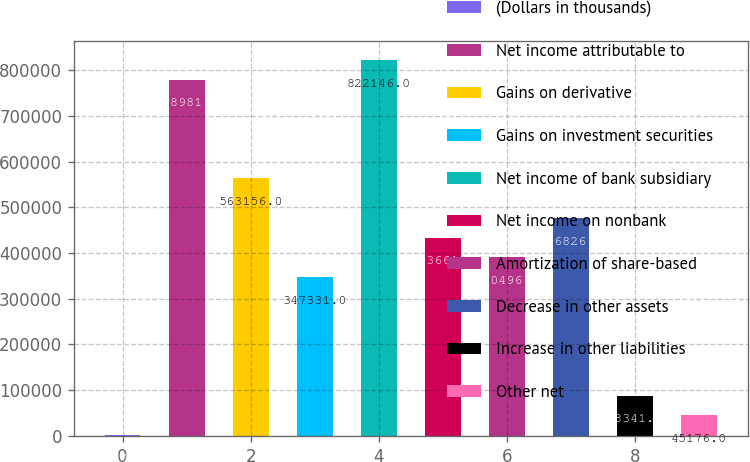Convert chart. <chart><loc_0><loc_0><loc_500><loc_500><bar_chart><fcel>(Dollars in thousands)<fcel>Net income attributable to<fcel>Gains on derivative<fcel>Gains on investment securities<fcel>Net income of bank subsidiary<fcel>Net income on nonbank<fcel>Amortization of share-based<fcel>Decrease in other assets<fcel>Increase in other liabilities<fcel>Other net<nl><fcel>2011<fcel>778981<fcel>563156<fcel>347331<fcel>822146<fcel>433661<fcel>390496<fcel>476826<fcel>88341<fcel>45176<nl></chart> 